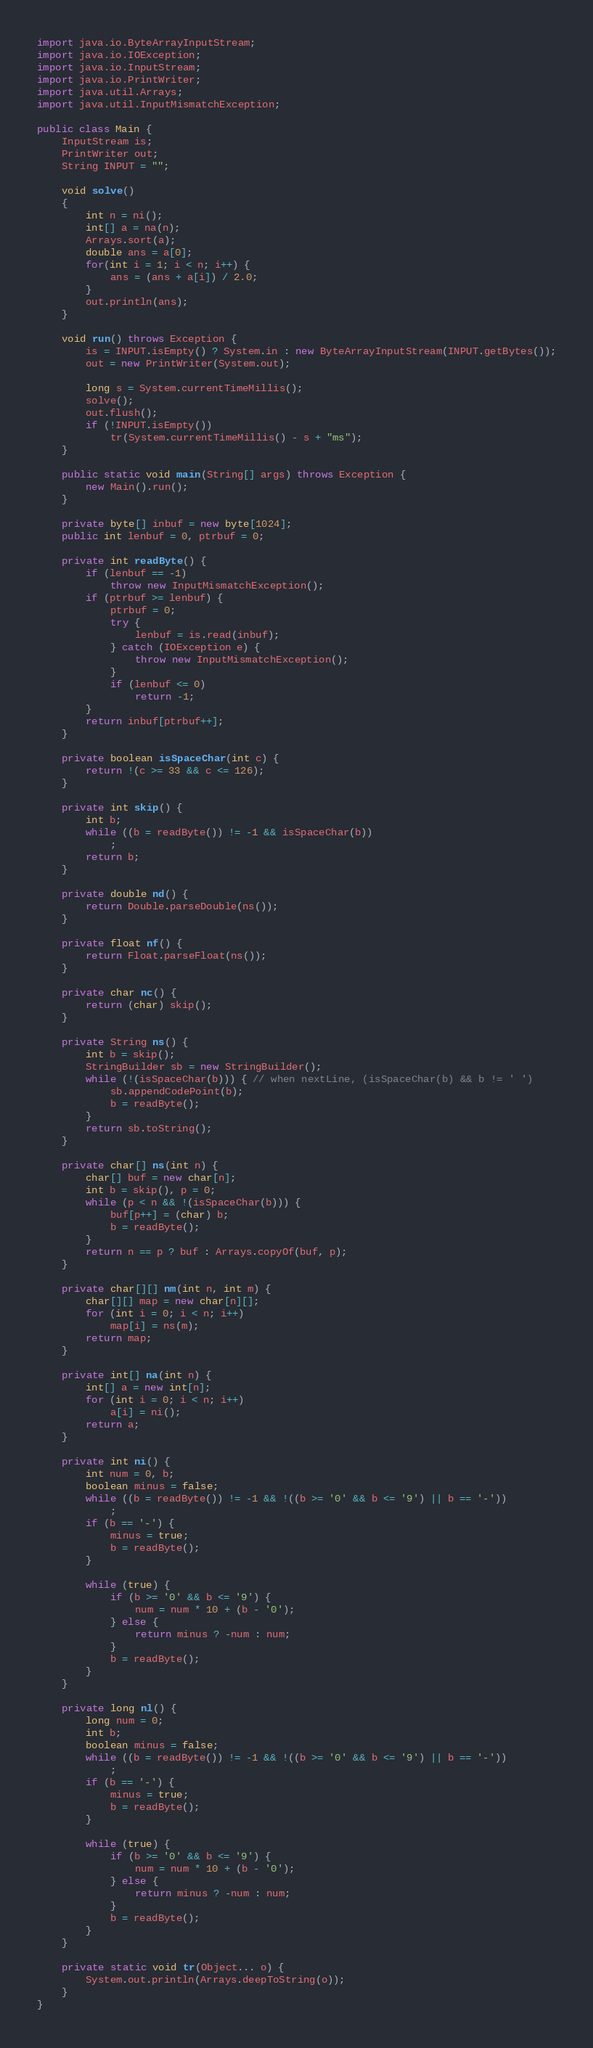Convert code to text. <code><loc_0><loc_0><loc_500><loc_500><_Java_>import java.io.ByteArrayInputStream;
import java.io.IOException;
import java.io.InputStream;
import java.io.PrintWriter;
import java.util.Arrays;
import java.util.InputMismatchException;

public class Main {
	InputStream is;
	PrintWriter out;
	String INPUT = "";

	void solve() 
	{
		int n = ni();
		int[] a = na(n);
		Arrays.sort(a);
		double ans = a[0];
		for(int i = 1; i < n; i++) {
			ans = (ans + a[i]) / 2.0;
		}
		out.println(ans);
	}
			
	void run() throws Exception {
		is = INPUT.isEmpty() ? System.in : new ByteArrayInputStream(INPUT.getBytes());
		out = new PrintWriter(System.out);

		long s = System.currentTimeMillis();
		solve();
		out.flush();
		if (!INPUT.isEmpty())
			tr(System.currentTimeMillis() - s + "ms");
	}

	public static void main(String[] args) throws Exception {
		new Main().run();
	}

	private byte[] inbuf = new byte[1024];
	public int lenbuf = 0, ptrbuf = 0;

	private int readByte() {
		if (lenbuf == -1)
			throw new InputMismatchException();
		if (ptrbuf >= lenbuf) {
			ptrbuf = 0;
			try {
				lenbuf = is.read(inbuf);
			} catch (IOException e) {
				throw new InputMismatchException();
			}
			if (lenbuf <= 0)
				return -1;
		}
		return inbuf[ptrbuf++];
	}

	private boolean isSpaceChar(int c) {
		return !(c >= 33 && c <= 126);
	}

	private int skip() {
		int b;
		while ((b = readByte()) != -1 && isSpaceChar(b))
			;
		return b;
	}

	private double nd() {
		return Double.parseDouble(ns());
	}

	private float nf() {
		return Float.parseFloat(ns());
	}

	private char nc() {
		return (char) skip();
	}

	private String ns() {
		int b = skip();
		StringBuilder sb = new StringBuilder();
		while (!(isSpaceChar(b))) { // when nextLine, (isSpaceChar(b) && b != ' ')
			sb.appendCodePoint(b);
			b = readByte();
		}
		return sb.toString();
	}

	private char[] ns(int n) {
		char[] buf = new char[n];
		int b = skip(), p = 0;
		while (p < n && !(isSpaceChar(b))) {
			buf[p++] = (char) b;
			b = readByte();
		}
		return n == p ? buf : Arrays.copyOf(buf, p);
	}

	private char[][] nm(int n, int m) {
		char[][] map = new char[n][];
		for (int i = 0; i < n; i++)
			map[i] = ns(m);
		return map;
	}

	private int[] na(int n) {
		int[] a = new int[n];
		for (int i = 0; i < n; i++)
			a[i] = ni();
		return a;
	}

	private int ni() {
		int num = 0, b;
		boolean minus = false;
		while ((b = readByte()) != -1 && !((b >= '0' && b <= '9') || b == '-'))
			;
		if (b == '-') {
			minus = true;
			b = readByte();
		}

		while (true) {
			if (b >= '0' && b <= '9') {
				num = num * 10 + (b - '0');
			} else {
				return minus ? -num : num;
			}
			b = readByte();
		}
	}

	private long nl() {
		long num = 0;
		int b;
		boolean minus = false;
		while ((b = readByte()) != -1 && !((b >= '0' && b <= '9') || b == '-'))
			;
		if (b == '-') {
			minus = true;
			b = readByte();
		}

		while (true) {
			if (b >= '0' && b <= '9') {
				num = num * 10 + (b - '0');
			} else {
				return minus ? -num : num;
			}
			b = readByte();
		}
	}

	private static void tr(Object... o) {
		System.out.println(Arrays.deepToString(o));
	}
}</code> 